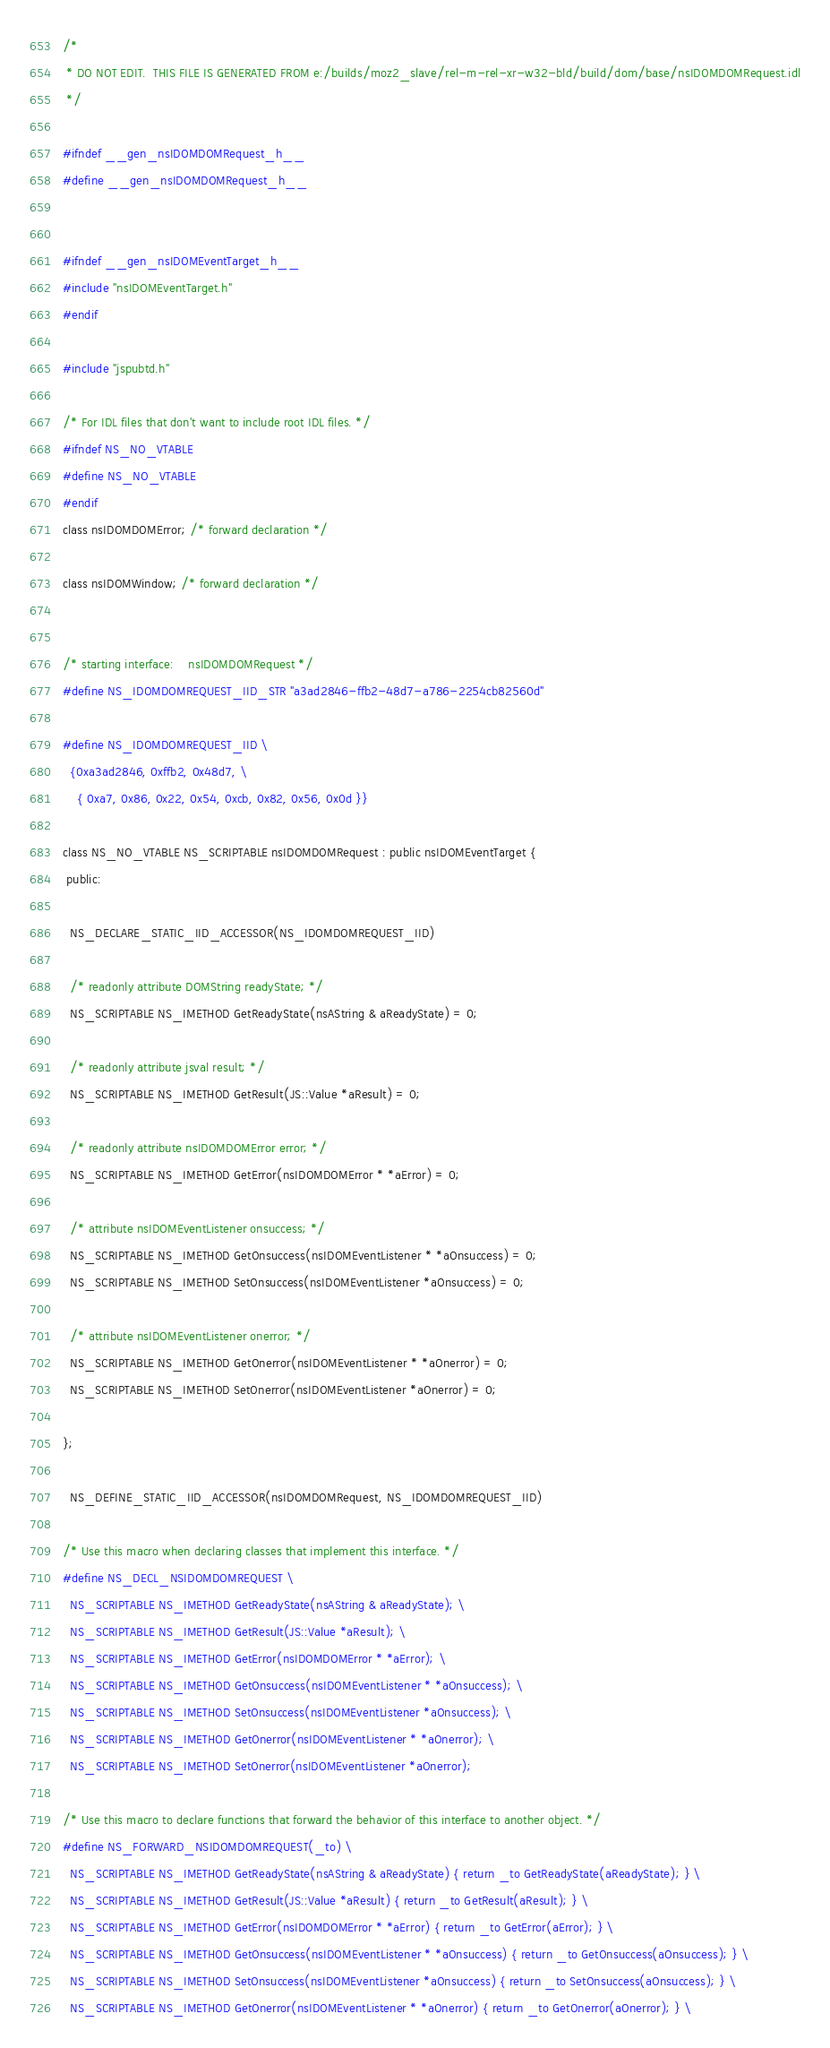<code> <loc_0><loc_0><loc_500><loc_500><_C_>/*
 * DO NOT EDIT.  THIS FILE IS GENERATED FROM e:/builds/moz2_slave/rel-m-rel-xr-w32-bld/build/dom/base/nsIDOMDOMRequest.idl
 */

#ifndef __gen_nsIDOMDOMRequest_h__
#define __gen_nsIDOMDOMRequest_h__


#ifndef __gen_nsIDOMEventTarget_h__
#include "nsIDOMEventTarget.h"
#endif

#include "jspubtd.h"

/* For IDL files that don't want to include root IDL files. */
#ifndef NS_NO_VTABLE
#define NS_NO_VTABLE
#endif
class nsIDOMDOMError; /* forward declaration */

class nsIDOMWindow; /* forward declaration */


/* starting interface:    nsIDOMDOMRequest */
#define NS_IDOMDOMREQUEST_IID_STR "a3ad2846-ffb2-48d7-a786-2254cb82560d"

#define NS_IDOMDOMREQUEST_IID \
  {0xa3ad2846, 0xffb2, 0x48d7, \
    { 0xa7, 0x86, 0x22, 0x54, 0xcb, 0x82, 0x56, 0x0d }}

class NS_NO_VTABLE NS_SCRIPTABLE nsIDOMDOMRequest : public nsIDOMEventTarget {
 public: 

  NS_DECLARE_STATIC_IID_ACCESSOR(NS_IDOMDOMREQUEST_IID)

  /* readonly attribute DOMString readyState; */
  NS_SCRIPTABLE NS_IMETHOD GetReadyState(nsAString & aReadyState) = 0;

  /* readonly attribute jsval result; */
  NS_SCRIPTABLE NS_IMETHOD GetResult(JS::Value *aResult) = 0;

  /* readonly attribute nsIDOMDOMError error; */
  NS_SCRIPTABLE NS_IMETHOD GetError(nsIDOMDOMError * *aError) = 0;

  /* attribute nsIDOMEventListener onsuccess; */
  NS_SCRIPTABLE NS_IMETHOD GetOnsuccess(nsIDOMEventListener * *aOnsuccess) = 0;
  NS_SCRIPTABLE NS_IMETHOD SetOnsuccess(nsIDOMEventListener *aOnsuccess) = 0;

  /* attribute nsIDOMEventListener onerror; */
  NS_SCRIPTABLE NS_IMETHOD GetOnerror(nsIDOMEventListener * *aOnerror) = 0;
  NS_SCRIPTABLE NS_IMETHOD SetOnerror(nsIDOMEventListener *aOnerror) = 0;

};

  NS_DEFINE_STATIC_IID_ACCESSOR(nsIDOMDOMRequest, NS_IDOMDOMREQUEST_IID)

/* Use this macro when declaring classes that implement this interface. */
#define NS_DECL_NSIDOMDOMREQUEST \
  NS_SCRIPTABLE NS_IMETHOD GetReadyState(nsAString & aReadyState); \
  NS_SCRIPTABLE NS_IMETHOD GetResult(JS::Value *aResult); \
  NS_SCRIPTABLE NS_IMETHOD GetError(nsIDOMDOMError * *aError); \
  NS_SCRIPTABLE NS_IMETHOD GetOnsuccess(nsIDOMEventListener * *aOnsuccess); \
  NS_SCRIPTABLE NS_IMETHOD SetOnsuccess(nsIDOMEventListener *aOnsuccess); \
  NS_SCRIPTABLE NS_IMETHOD GetOnerror(nsIDOMEventListener * *aOnerror); \
  NS_SCRIPTABLE NS_IMETHOD SetOnerror(nsIDOMEventListener *aOnerror); 

/* Use this macro to declare functions that forward the behavior of this interface to another object. */
#define NS_FORWARD_NSIDOMDOMREQUEST(_to) \
  NS_SCRIPTABLE NS_IMETHOD GetReadyState(nsAString & aReadyState) { return _to GetReadyState(aReadyState); } \
  NS_SCRIPTABLE NS_IMETHOD GetResult(JS::Value *aResult) { return _to GetResult(aResult); } \
  NS_SCRIPTABLE NS_IMETHOD GetError(nsIDOMDOMError * *aError) { return _to GetError(aError); } \
  NS_SCRIPTABLE NS_IMETHOD GetOnsuccess(nsIDOMEventListener * *aOnsuccess) { return _to GetOnsuccess(aOnsuccess); } \
  NS_SCRIPTABLE NS_IMETHOD SetOnsuccess(nsIDOMEventListener *aOnsuccess) { return _to SetOnsuccess(aOnsuccess); } \
  NS_SCRIPTABLE NS_IMETHOD GetOnerror(nsIDOMEventListener * *aOnerror) { return _to GetOnerror(aOnerror); } \</code> 